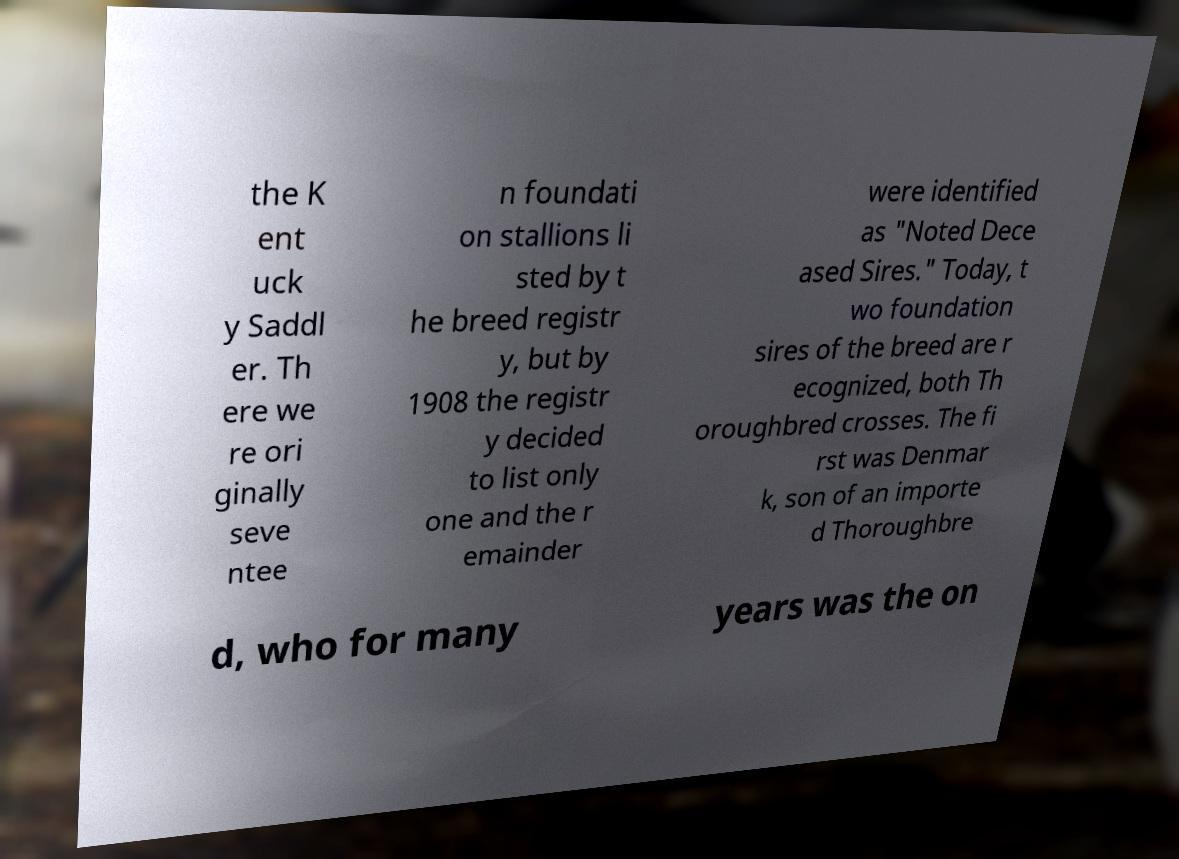Can you read and provide the text displayed in the image?This photo seems to have some interesting text. Can you extract and type it out for me? the K ent uck y Saddl er. Th ere we re ori ginally seve ntee n foundati on stallions li sted by t he breed registr y, but by 1908 the registr y decided to list only one and the r emainder were identified as "Noted Dece ased Sires." Today, t wo foundation sires of the breed are r ecognized, both Th oroughbred crosses. The fi rst was Denmar k, son of an importe d Thoroughbre d, who for many years was the on 